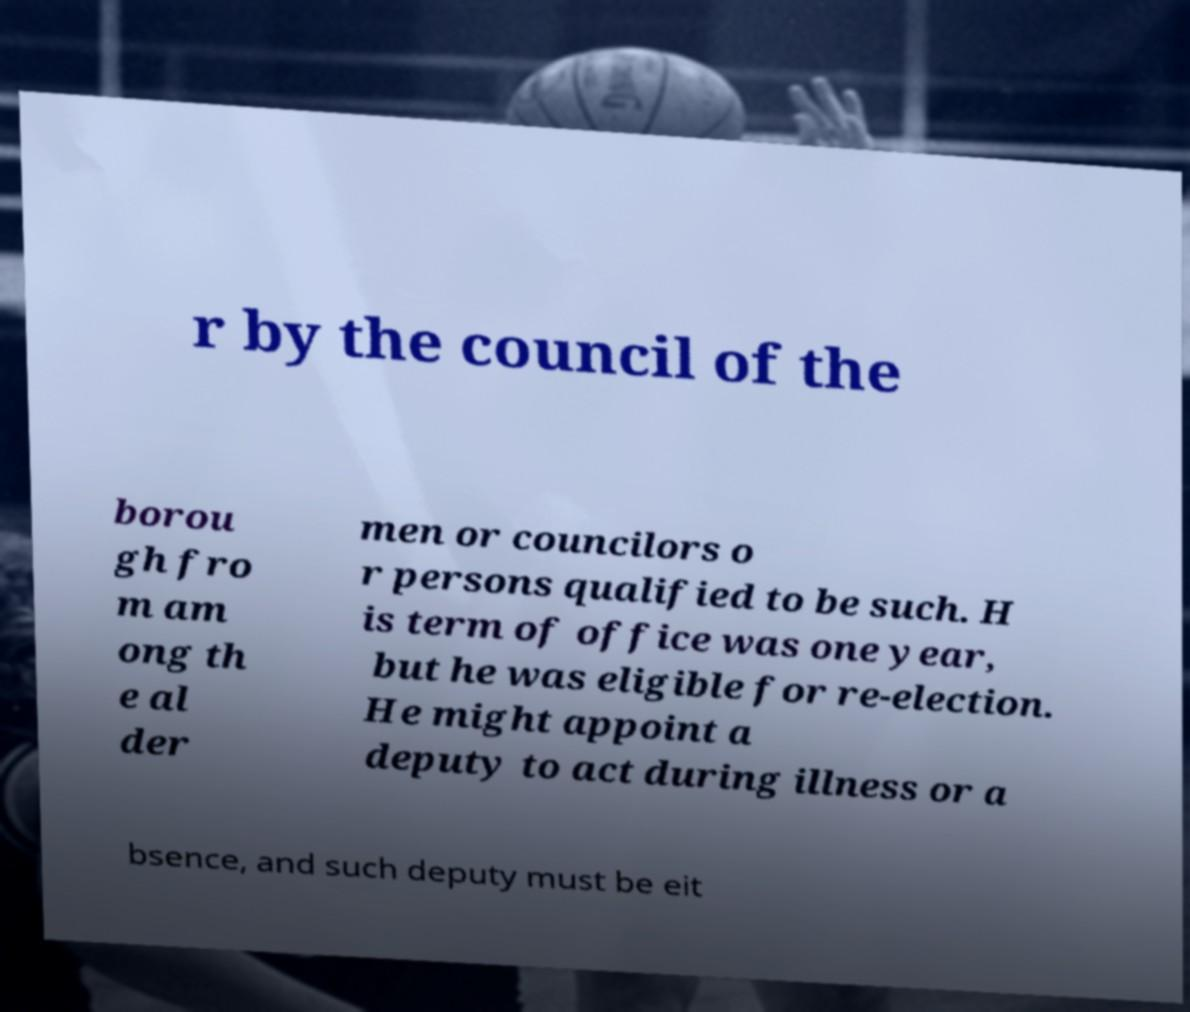What messages or text are displayed in this image? I need them in a readable, typed format. r by the council of the borou gh fro m am ong th e al der men or councilors o r persons qualified to be such. H is term of office was one year, but he was eligible for re-election. He might appoint a deputy to act during illness or a bsence, and such deputy must be eit 